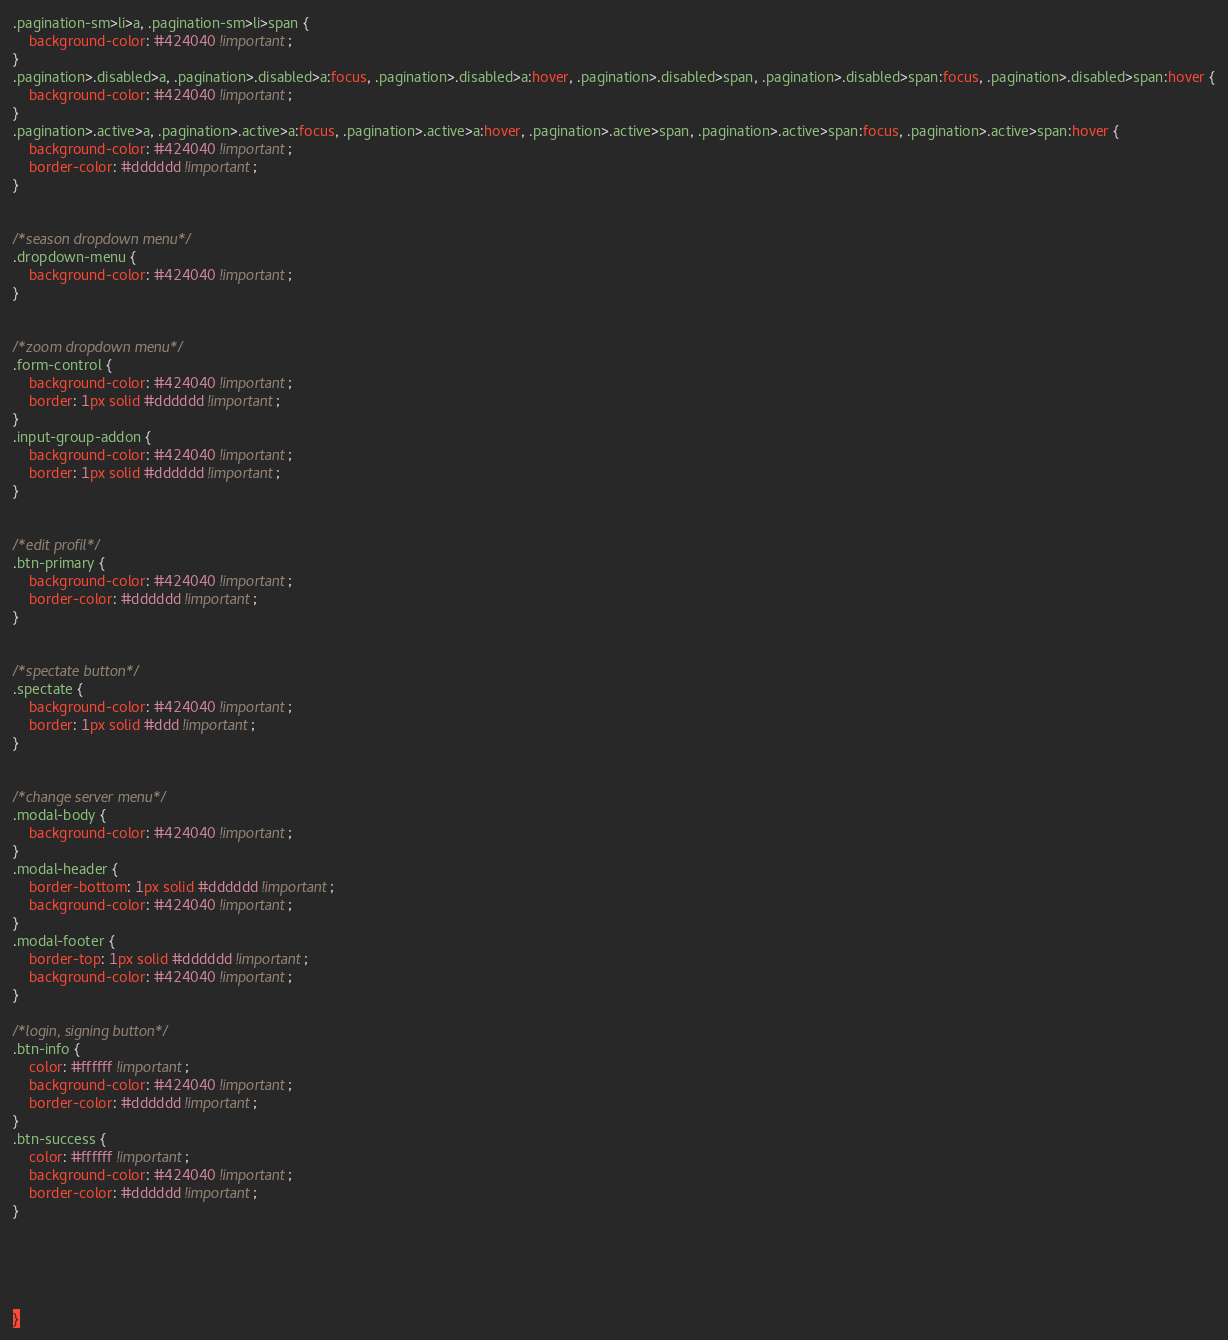Convert code to text. <code><loc_0><loc_0><loc_500><loc_500><_CSS_>.pagination-sm>li>a, .pagination-sm>li>span {
    background-color: #424040 !important;
}
.pagination>.disabled>a, .pagination>.disabled>a:focus, .pagination>.disabled>a:hover, .pagination>.disabled>span, .pagination>.disabled>span:focus, .pagination>.disabled>span:hover {
    background-color: #424040 !important;
}
.pagination>.active>a, .pagination>.active>a:focus, .pagination>.active>a:hover, .pagination>.active>span, .pagination>.active>span:focus, .pagination>.active>span:hover {
    background-color: #424040 !important;
    border-color: #dddddd !important;
}


/*season dropdown menu*/
.dropdown-menu {
    background-color: #424040 !important;
}


/*zoom dropdown menu*/
.form-control {
    background-color: #424040 !important;
    border: 1px solid #dddddd !important;
}
.input-group-addon {
    background-color: #424040 !important;
    border: 1px solid #dddddd !important;
}


/*edit profil*/
.btn-primary {
    background-color: #424040 !important;
    border-color: #dddddd !important;
}


/*spectate button*/
.spectate {
    background-color: #424040 !important;
    border: 1px solid #ddd !important;
}


/*change server menu*/
.modal-body {
    background-color: #424040 !important;
}
.modal-header {
    border-bottom: 1px solid #dddddd !important;
    background-color: #424040 !important;
}
.modal-footer {
    border-top: 1px solid #dddddd !important;
    background-color: #424040 !important;
}

/*login, signing button*/
.btn-info {
    color: #ffffff !important;
    background-color: #424040 !important;
    border-color: #dddddd !important;
}
.btn-success {
    color: #ffffff !important;
    background-color: #424040 !important;
    border-color: #dddddd !important;
}





}</code> 